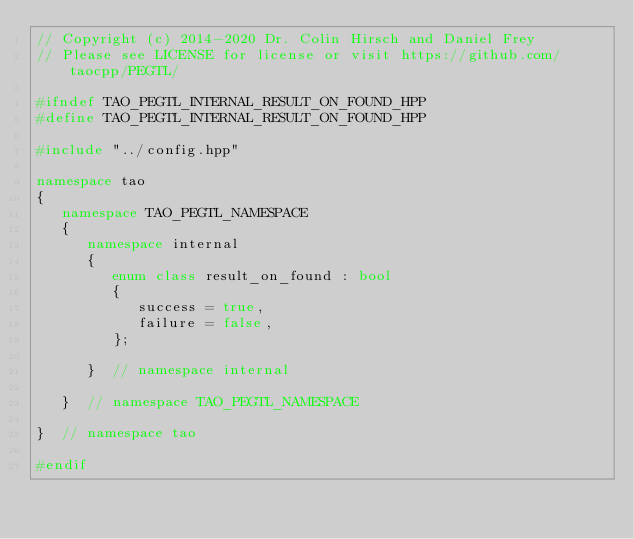<code> <loc_0><loc_0><loc_500><loc_500><_C++_>// Copyright (c) 2014-2020 Dr. Colin Hirsch and Daniel Frey
// Please see LICENSE for license or visit https://github.com/taocpp/PEGTL/

#ifndef TAO_PEGTL_INTERNAL_RESULT_ON_FOUND_HPP
#define TAO_PEGTL_INTERNAL_RESULT_ON_FOUND_HPP

#include "../config.hpp"

namespace tao
{
   namespace TAO_PEGTL_NAMESPACE
   {
      namespace internal
      {
         enum class result_on_found : bool
         {
            success = true,
            failure = false,
         };

      }  // namespace internal

   }  // namespace TAO_PEGTL_NAMESPACE

}  // namespace tao

#endif
</code> 